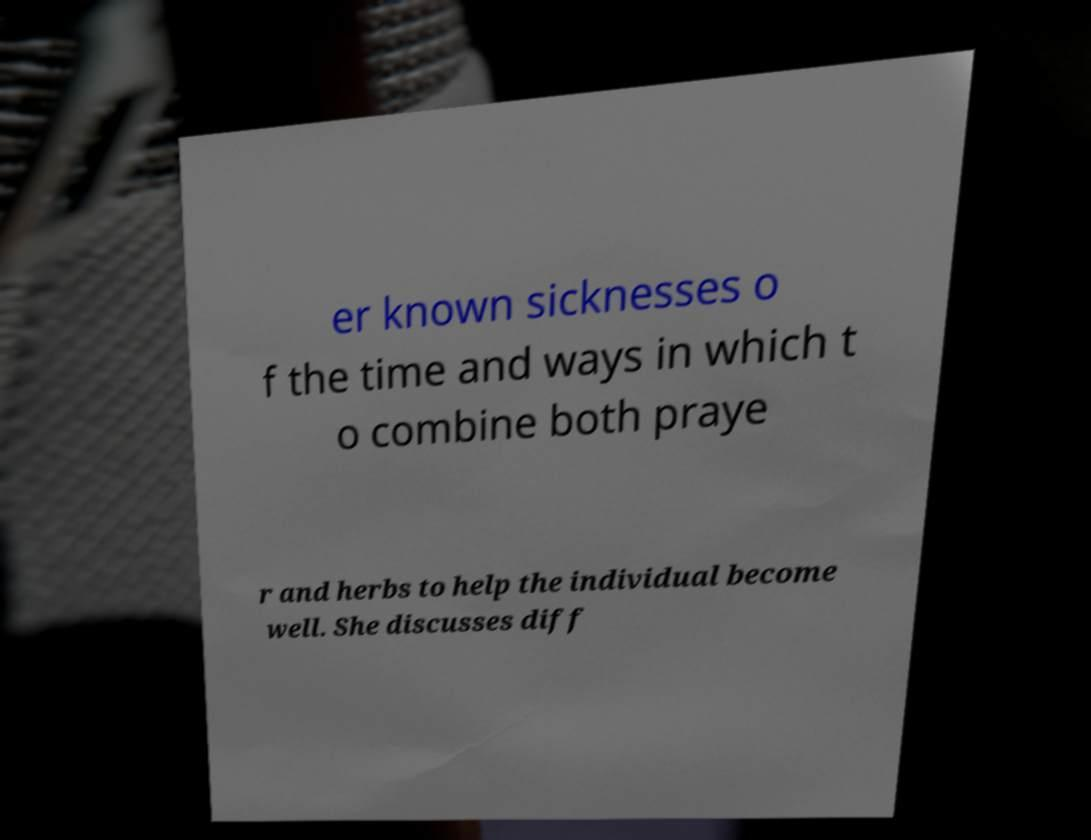Can you read and provide the text displayed in the image?This photo seems to have some interesting text. Can you extract and type it out for me? er known sicknesses o f the time and ways in which t o combine both praye r and herbs to help the individual become well. She discusses diff 